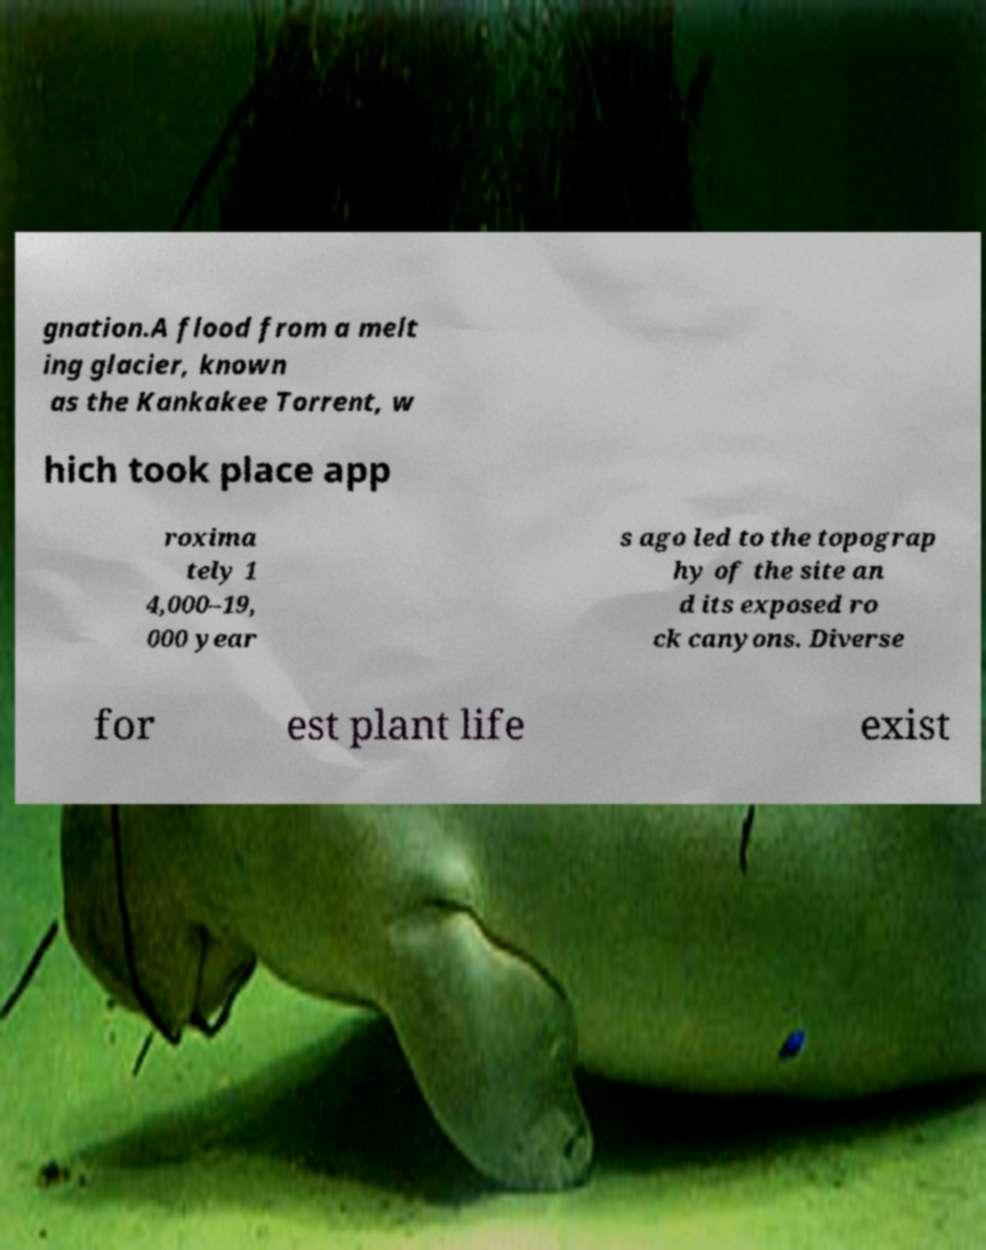For documentation purposes, I need the text within this image transcribed. Could you provide that? gnation.A flood from a melt ing glacier, known as the Kankakee Torrent, w hich took place app roxima tely 1 4,000–19, 000 year s ago led to the topograp hy of the site an d its exposed ro ck canyons. Diverse for est plant life exist 